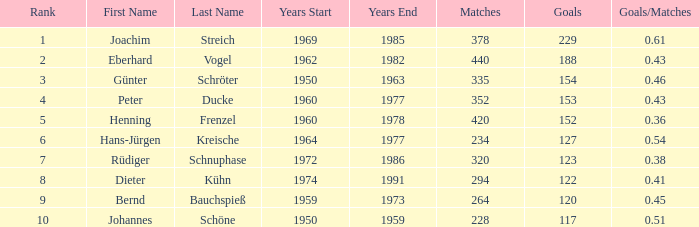With joachim streich as the name and more than 378 matches, what is the smallest goal that has a goals/matches ratio higher than 0.43? None. 